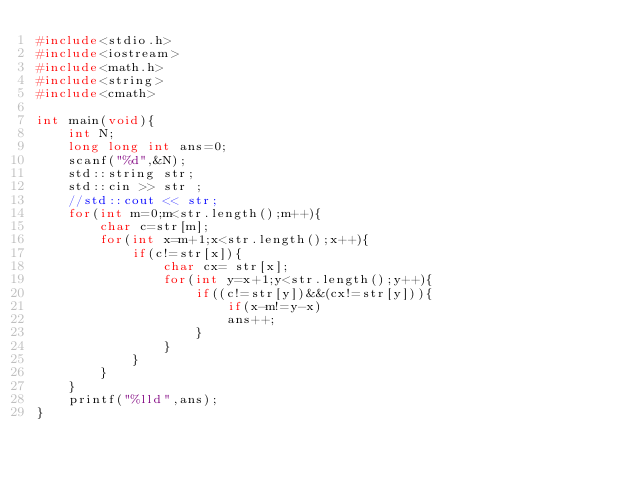Convert code to text. <code><loc_0><loc_0><loc_500><loc_500><_C++_>#include<stdio.h>
#include<iostream>
#include<math.h>
#include<string>
#include<cmath>
 
int main(void){
    int N;
    long long int ans=0;
    scanf("%d",&N);
    std::string str;
    std::cin >> str ;
    //std::cout << str;
    for(int m=0;m<str.length();m++){
        char c=str[m];
        for(int x=m+1;x<str.length();x++){
            if(c!=str[x]){
                char cx= str[x];
                for(int y=x+1;y<str.length();y++){
                    if((c!=str[y])&&(cx!=str[y])){
                        if(x-m!=y-x)
                        ans++;
                    }
                }
            }
        }
    }
    printf("%lld",ans);
}</code> 